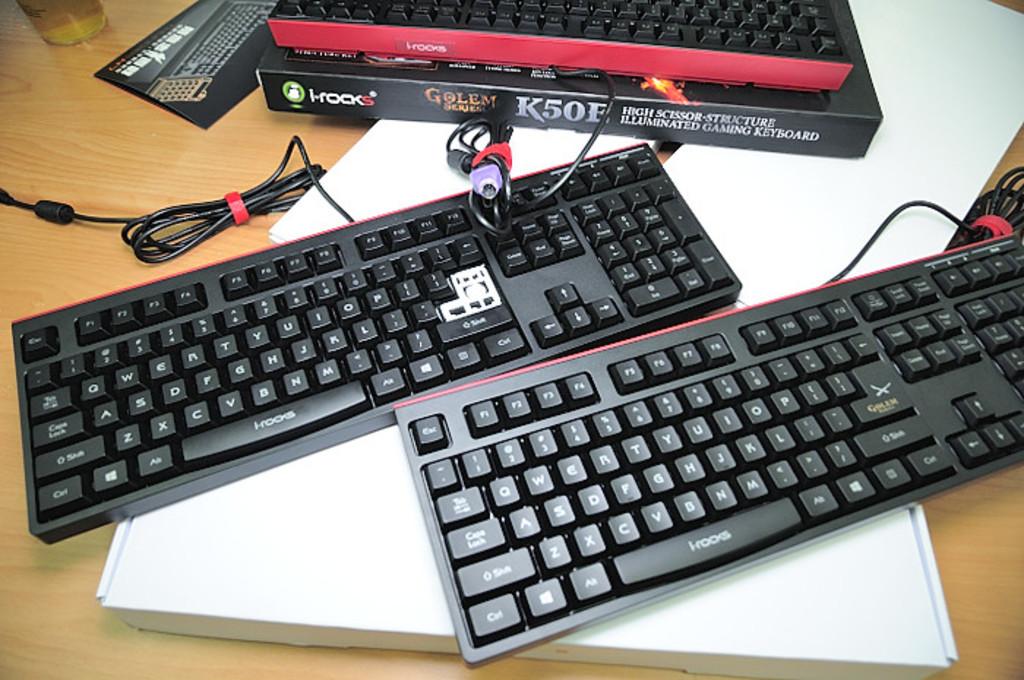What is the brand of these keyboards?
Provide a succinct answer. I-rocks. What model number are these keyboards?
Ensure brevity in your answer.  K50e. 